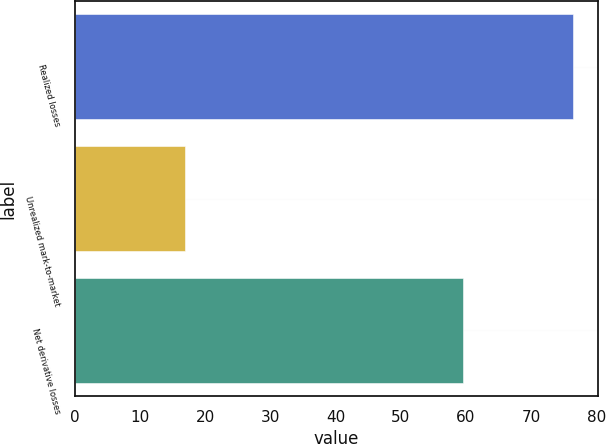Convert chart to OTSL. <chart><loc_0><loc_0><loc_500><loc_500><bar_chart><fcel>Realized losses<fcel>Unrealized mark-to-market<fcel>Net derivative losses<nl><fcel>76.5<fcel>17<fcel>59.5<nl></chart> 